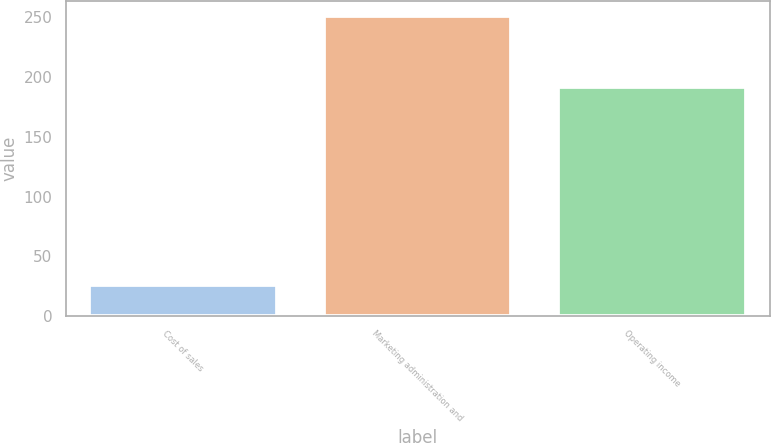<chart> <loc_0><loc_0><loc_500><loc_500><bar_chart><fcel>Cost of sales<fcel>Marketing administration and<fcel>Operating income<nl><fcel>26<fcel>251<fcel>192<nl></chart> 